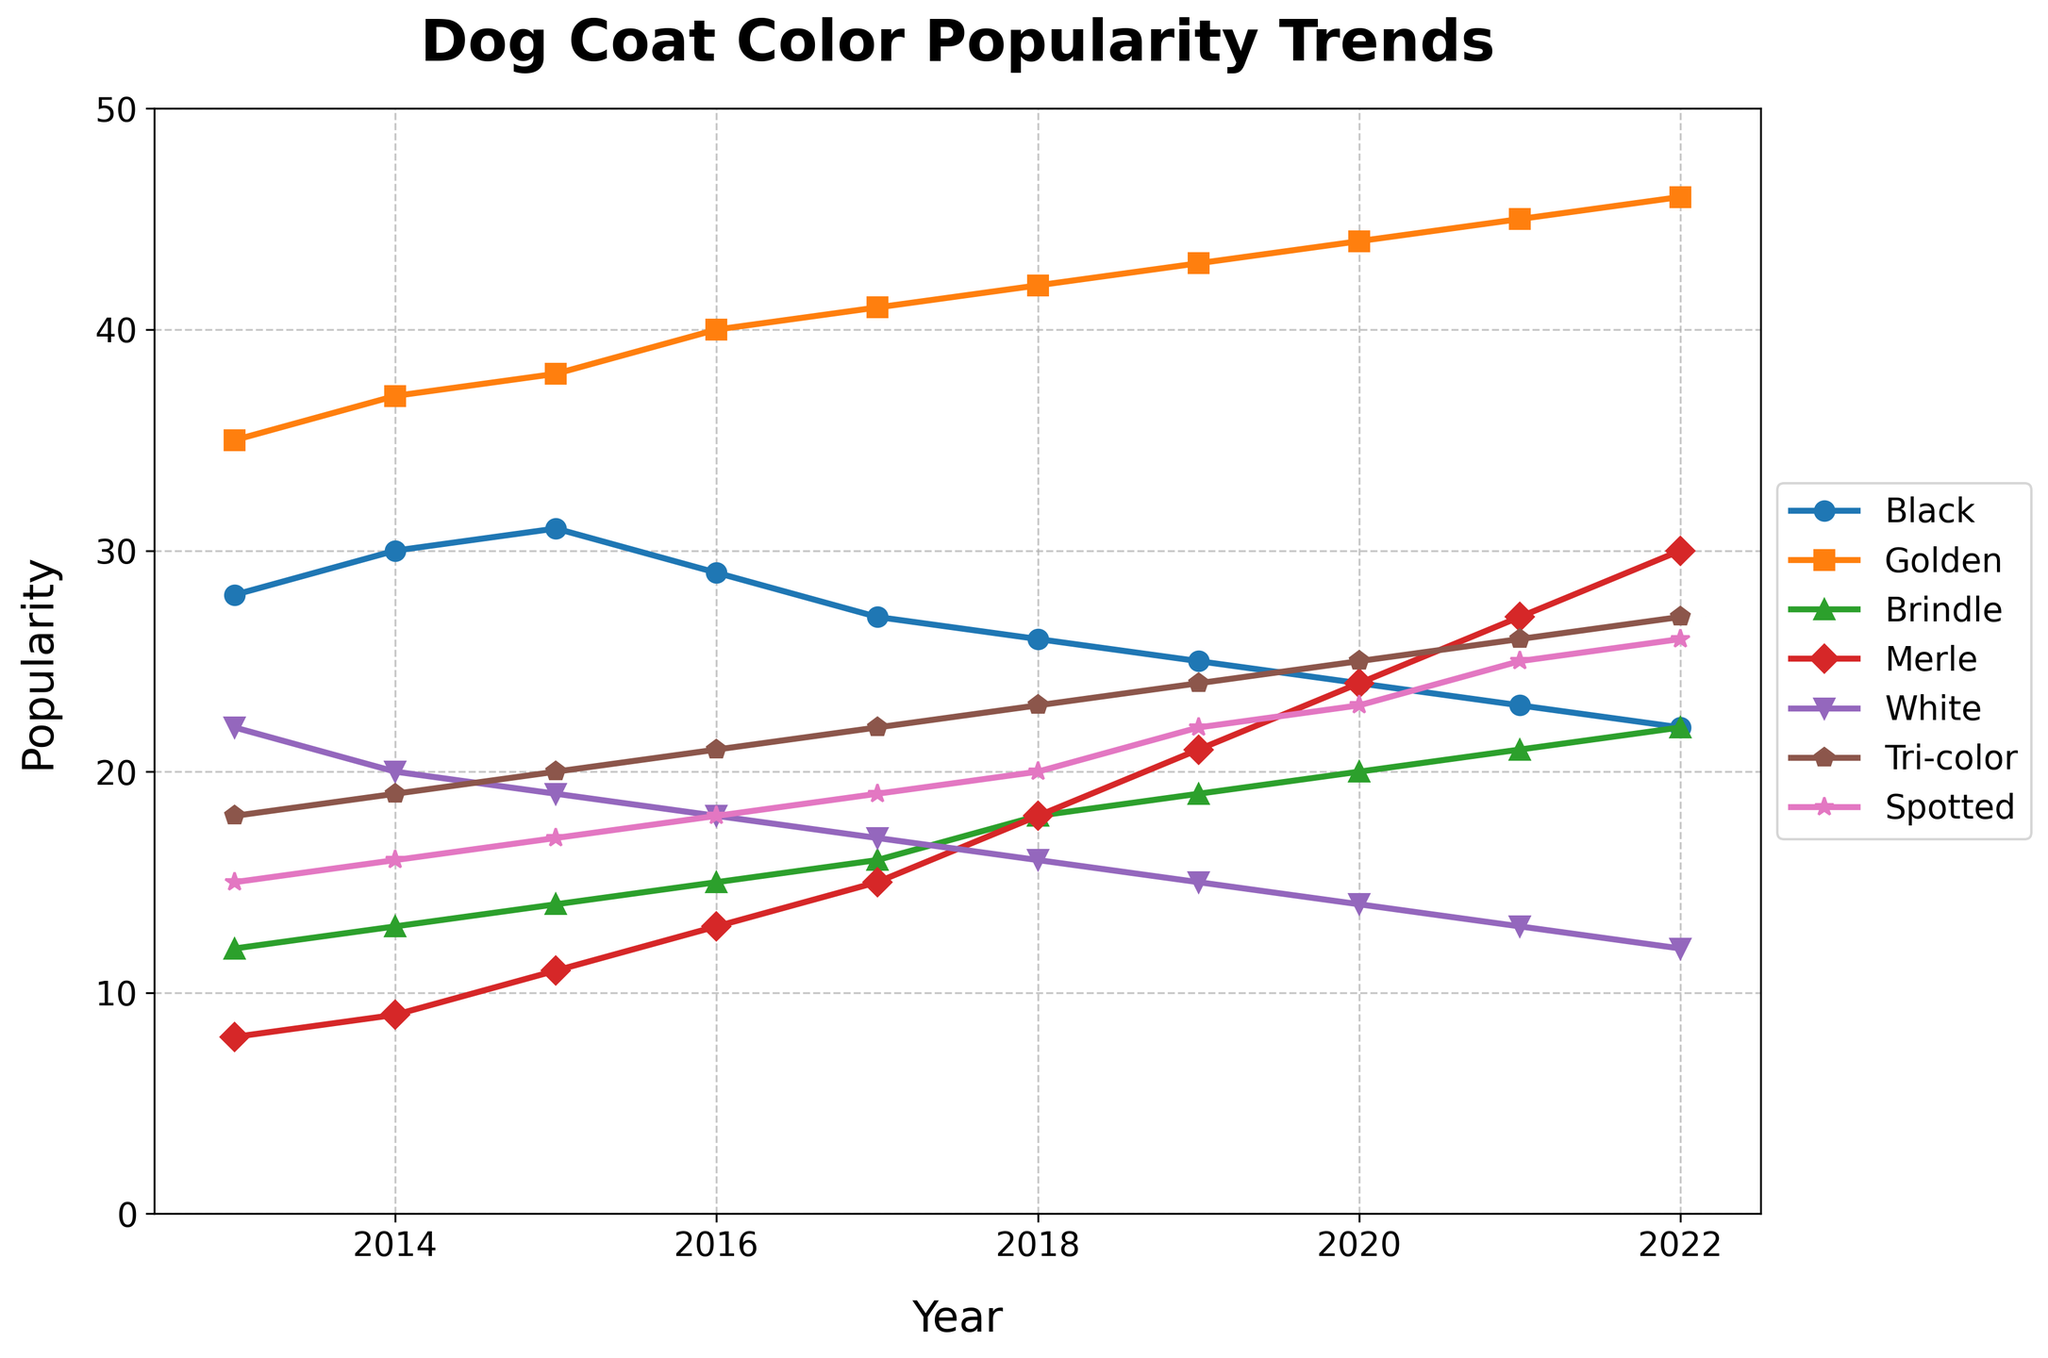What's the most popular dog coat color in 2022? To find the most popular dog coat color in 2022, look at the values for each coat color in 2022 and identify the highest number. The popularity values in 2022 are: Black (22), Golden (46), Brindle (22), Merle (30), White (12), Tri-color (27), Spotted (26). The highest value is for Golden with 46.
Answer: Golden Which dog coat color shows the largest increase in popularity between 2013 and 2022? Calculate the difference in popularity for each coat color between 2013 and 2022. Black: 22 - 28 = -6, Golden: 46 - 35 = 11, Brindle: 22 - 12 = 10, Merle: 30 - 8 = 22, White: 12 - 22 = -10, Tri-color: 27 - 18 = 9, Spotted: 26 - 15 = 11. The largest increase is for Merle with an increase of 22.
Answer: Merle Which dog coat color had a consistent increase in popularity every year? Inspect each dog coat color line and check if they increase every consecutive year from 2013 to 2022. Golden, Merle, Tri-color, and Spotted show consistent increases each year. The other colors have fluctuating or decreasing trends in some years.
Answer: Golden, Merle, Tri-color, Spotted In which year did the 'Brindle' coat color surpass 'Black' in popularity? Compare the popularity of 'Brindle' and 'Black' each year until 'Brindle' has a higher value than 'Black'. In 2020, Brindle (20) surpasses Black (24).
Answer: 2020 What is the average popularity of the 'Tri-color' coat over the 10 years? Sum the popularity values for 'Tri-color' from 2013 to 2022 and divide by 10. The values are 18, 19, 20, 21, 22, 23, 24, 25, 26, 27. Sum = 225. Average = 225 / 10 = 22.5
Answer: 22.5 Which coat color was the least popular in 2015, and what was its popularity? Look at the popularity values for each coat color in 2015 and identify the smallest number. The values are: Black (31), Golden (38), Brindle (14), Merle (11), White (19), Tri-color (20), Spotted (17). The least popular color is Merle with 11.
Answer: Merle, 11 How does the popularity of 'Spotted' in 2018 compare to 'White' in the same year? Compare the popularity values for 'Spotted' and 'White' in 2018. Spotted has a value of 20 and White has a value of 16. Since 20 > 16, Spotted is more popular.
Answer: Spotted is more popular What was the general trend for the 'White' coat color over the decade? Examine the trend of the 'White' coat color over the years from 2013 to 2022. The popularity values decrease from 22 in 2013 to 12 in 2022, showing a general decreasing trend.
Answer: Decreasing In which years were the popularity of 'Black' and 'Brindle' the same? Identify and compare the years where the popularity values for 'Black' and 'Brindle' are equal. Both colors have a popularity of 22 in 2022.
Answer: 2022 What is the difference between the highest and lowest popularity of the 'Golden' coat color from 2013 to 2022? Find the maximum and minimum popularity values of Golden over the years. The maximum is 46 in 2022, and the minimum is 35 in 2013. Difference = 46 - 35 = 11
Answer: 11 